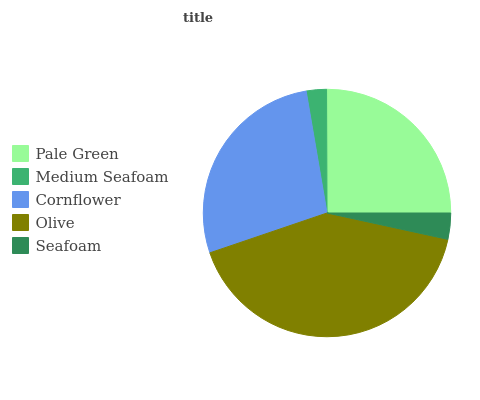Is Medium Seafoam the minimum?
Answer yes or no. Yes. Is Olive the maximum?
Answer yes or no. Yes. Is Cornflower the minimum?
Answer yes or no. No. Is Cornflower the maximum?
Answer yes or no. No. Is Cornflower greater than Medium Seafoam?
Answer yes or no. Yes. Is Medium Seafoam less than Cornflower?
Answer yes or no. Yes. Is Medium Seafoam greater than Cornflower?
Answer yes or no. No. Is Cornflower less than Medium Seafoam?
Answer yes or no. No. Is Pale Green the high median?
Answer yes or no. Yes. Is Pale Green the low median?
Answer yes or no. Yes. Is Medium Seafoam the high median?
Answer yes or no. No. Is Medium Seafoam the low median?
Answer yes or no. No. 